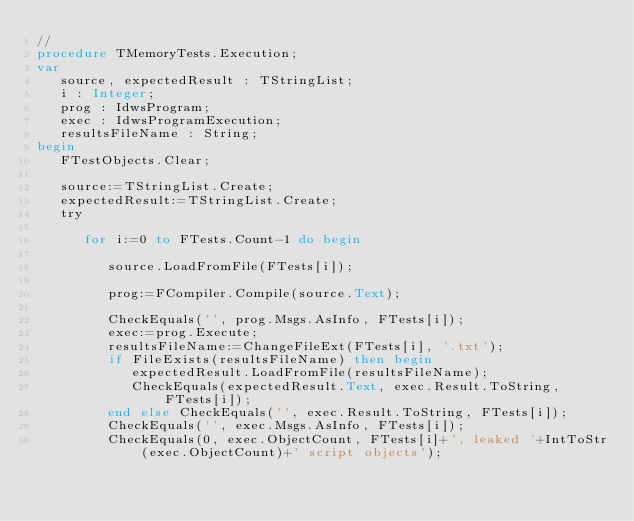<code> <loc_0><loc_0><loc_500><loc_500><_Pascal_>//
procedure TMemoryTests.Execution;
var
   source, expectedResult : TStringList;
   i : Integer;
   prog : IdwsProgram;
   exec : IdwsProgramExecution;
   resultsFileName : String;
begin
   FTestObjects.Clear;

   source:=TStringList.Create;
   expectedResult:=TStringList.Create;
   try

      for i:=0 to FTests.Count-1 do begin

         source.LoadFromFile(FTests[i]);

         prog:=FCompiler.Compile(source.Text);

         CheckEquals('', prog.Msgs.AsInfo, FTests[i]);
         exec:=prog.Execute;
         resultsFileName:=ChangeFileExt(FTests[i], '.txt');
         if FileExists(resultsFileName) then begin
            expectedResult.LoadFromFile(resultsFileName);
            CheckEquals(expectedResult.Text, exec.Result.ToString, FTests[i]);
         end else CheckEquals('', exec.Result.ToString, FTests[i]);
         CheckEquals('', exec.Msgs.AsInfo, FTests[i]);
         CheckEquals(0, exec.ObjectCount, FTests[i]+', leaked '+IntToStr(exec.ObjectCount)+' script objects');</code> 